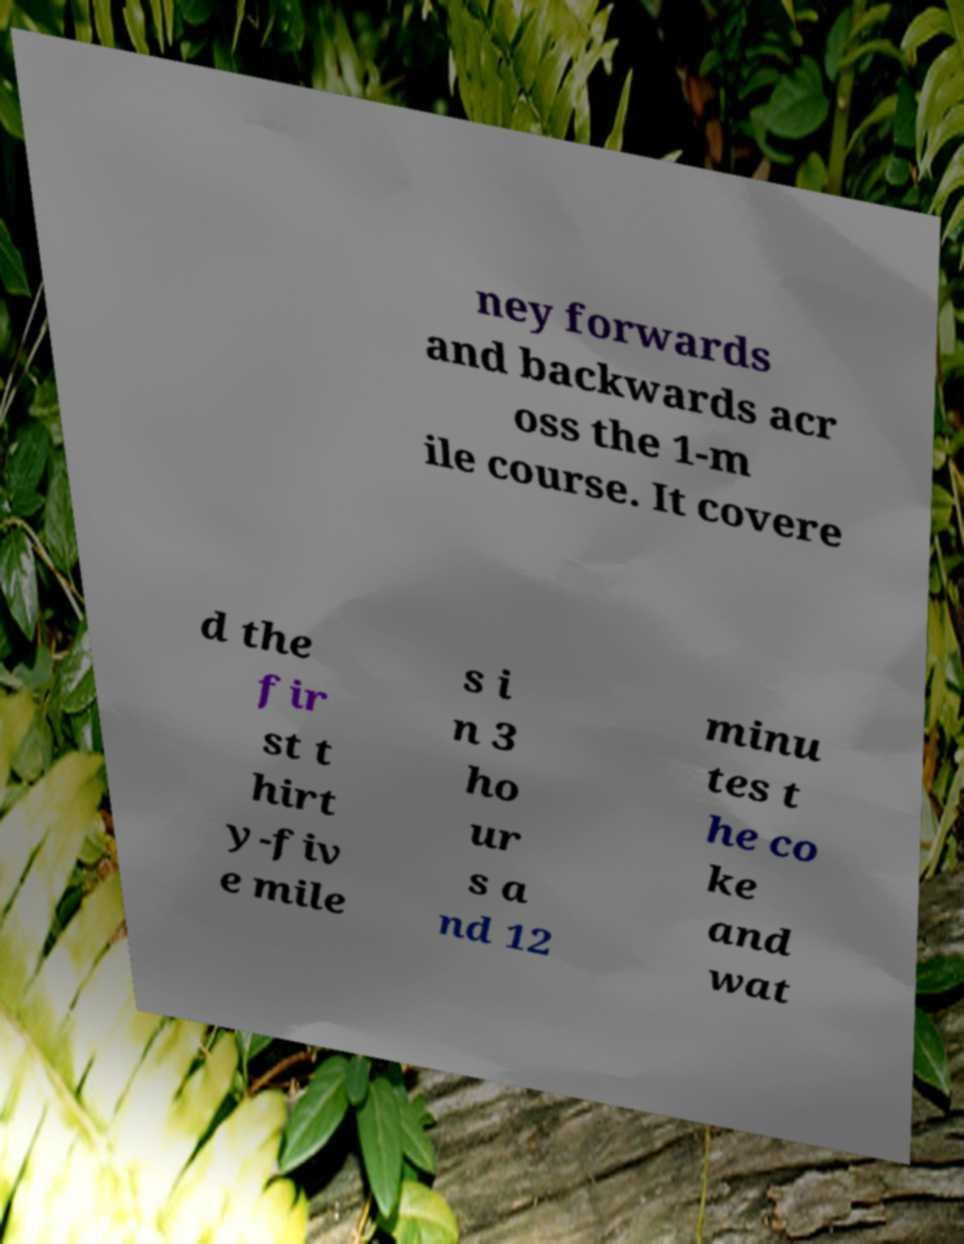Can you accurately transcribe the text from the provided image for me? ney forwards and backwards acr oss the 1-m ile course. It covere d the fir st t hirt y-fiv e mile s i n 3 ho ur s a nd 12 minu tes t he co ke and wat 